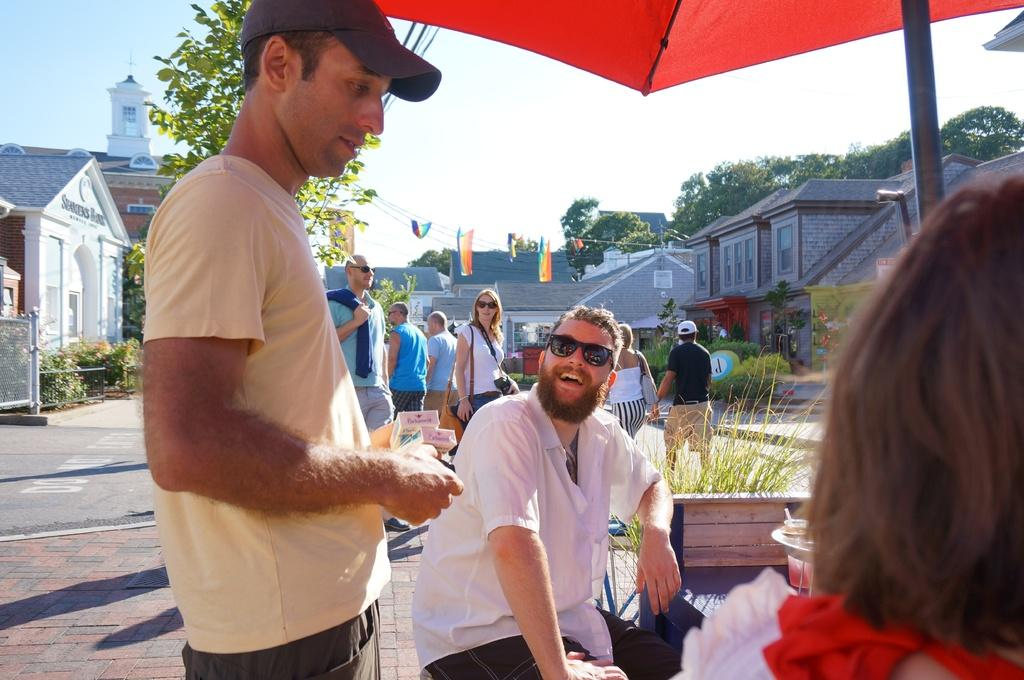Who or what can be seen in the image? There are people in the image. What can be seen in the distance behind the people? There are buildings, trees, and the sky visible in the background of the image. Can you describe the tent in the image? Yes, there is a tent at the top of the image. What type of notebook is being used by the tramp in the image? There is no tramp or notebook present in the image. 